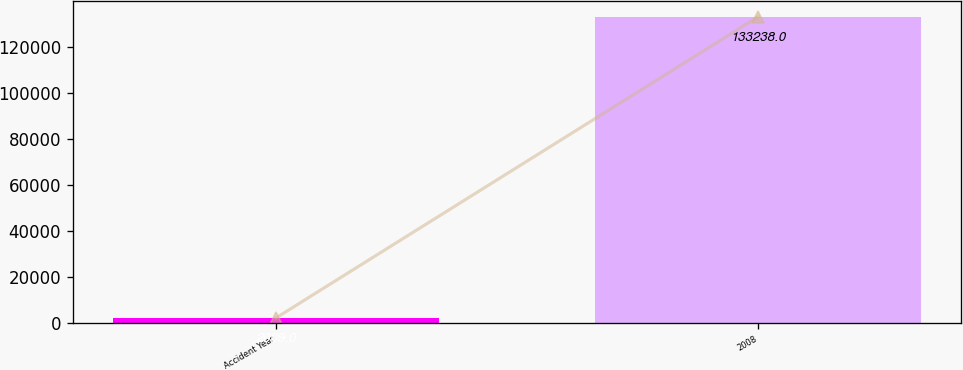Convert chart. <chart><loc_0><loc_0><loc_500><loc_500><bar_chart><fcel>Accident Year<fcel>2008<nl><fcel>2009<fcel>133238<nl></chart> 